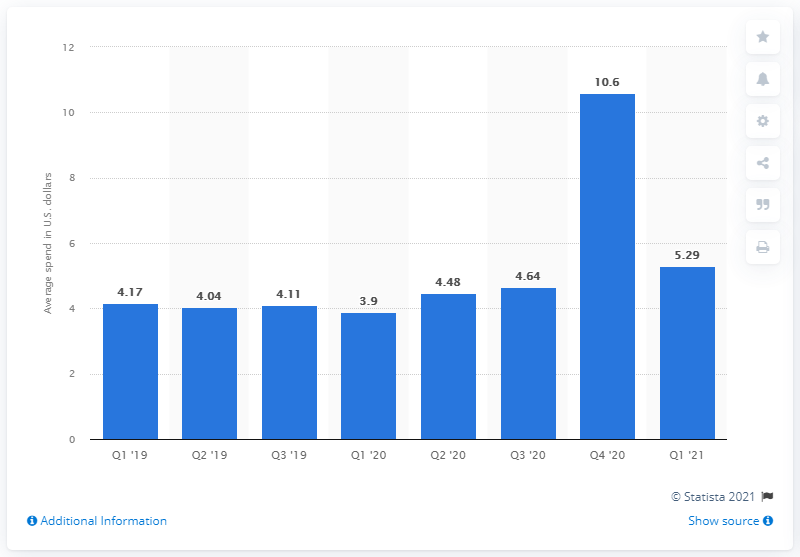Draw attention to some important aspects in this diagram. The average amount that consumers spent on mobile apps per smartphone during the first quarter of 2020 was approximately $5.29. 